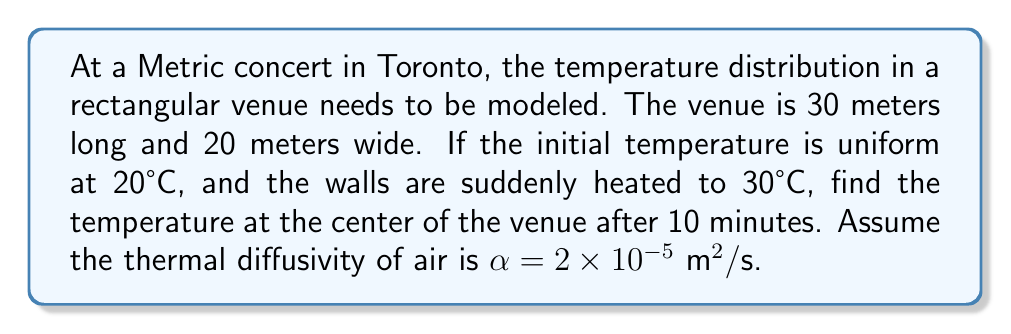Help me with this question. To solve this problem, we'll use the 2D heat equation:

$$\frac{\partial u}{\partial t} = \alpha \left(\frac{\partial^2 u}{\partial x^2} + \frac{\partial^2 u}{\partial y^2}\right)$$

Given the boundary conditions, we can use the solution:

$$u(x,y,t) = u_0 + (u_1 - u_0)\left(1 - \frac{16}{\pi^2}\sum_{m=1,3,5,...}^{\infty}\sum_{n=1,3,5,...}^{\infty}\frac{1}{mn}\sin\frac{m\pi x}{L_x}\sin\frac{n\pi y}{L_y}e^{-\alpha\pi^2t(\frac{m^2}{L_x^2}+\frac{n^2}{L_y^2})}\right)$$

Where:
$u_0 = 20°C$ (initial temperature)
$u_1 = 30°C$ (wall temperature)
$L_x = 30$ m (length)
$L_y = 20$ m (width)
$\alpha = 2 \times 10^{-5} \text{ m}^2/\text{s}$ (thermal diffusivity)
$t = 600$ s (10 minutes)
$x = 15$ m, $y = 10$ m (center point)

Let's calculate the first few terms of the series:

For $m=n=1$:
$$\frac{1}{1\cdot1}\sin\frac{\pi\cdot15}{30}\sin\frac{\pi\cdot10}{20}e^{-2\times10^{-5}\cdot\pi^2\cdot600(\frac{1^2}{30^2}+\frac{1^2}{20^2})} \approx 0.9997$$

For $m=1, n=3$:
$$\frac{1}{1\cdot3}\sin\frac{\pi\cdot15}{30}\sin\frac{3\pi\cdot10}{20}e^{-2\times10^{-5}\cdot\pi^2\cdot600(\frac{1^2}{30^2}+\frac{3^2}{20^2})} \approx 0$$

Higher terms become negligible quickly. Using only the first term:

$$u(15,10,600) \approx 20 + (30-20)\left(1 - \frac{16}{\pi^2}\cdot0.9997\right) \approx 20.97°C$$
Answer: 20.97°C 